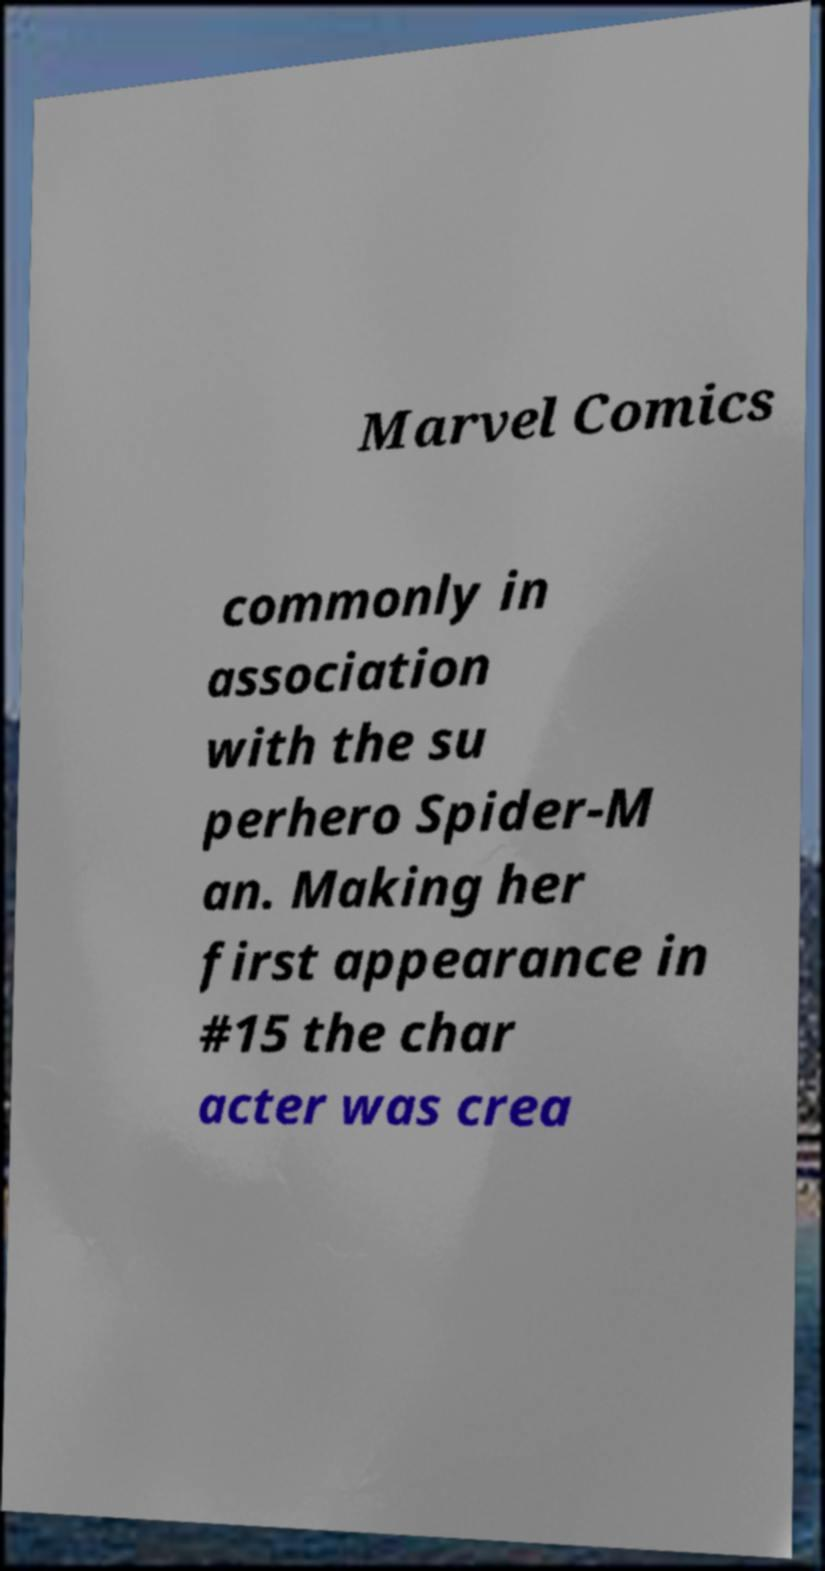For documentation purposes, I need the text within this image transcribed. Could you provide that? Marvel Comics commonly in association with the su perhero Spider-M an. Making her first appearance in #15 the char acter was crea 